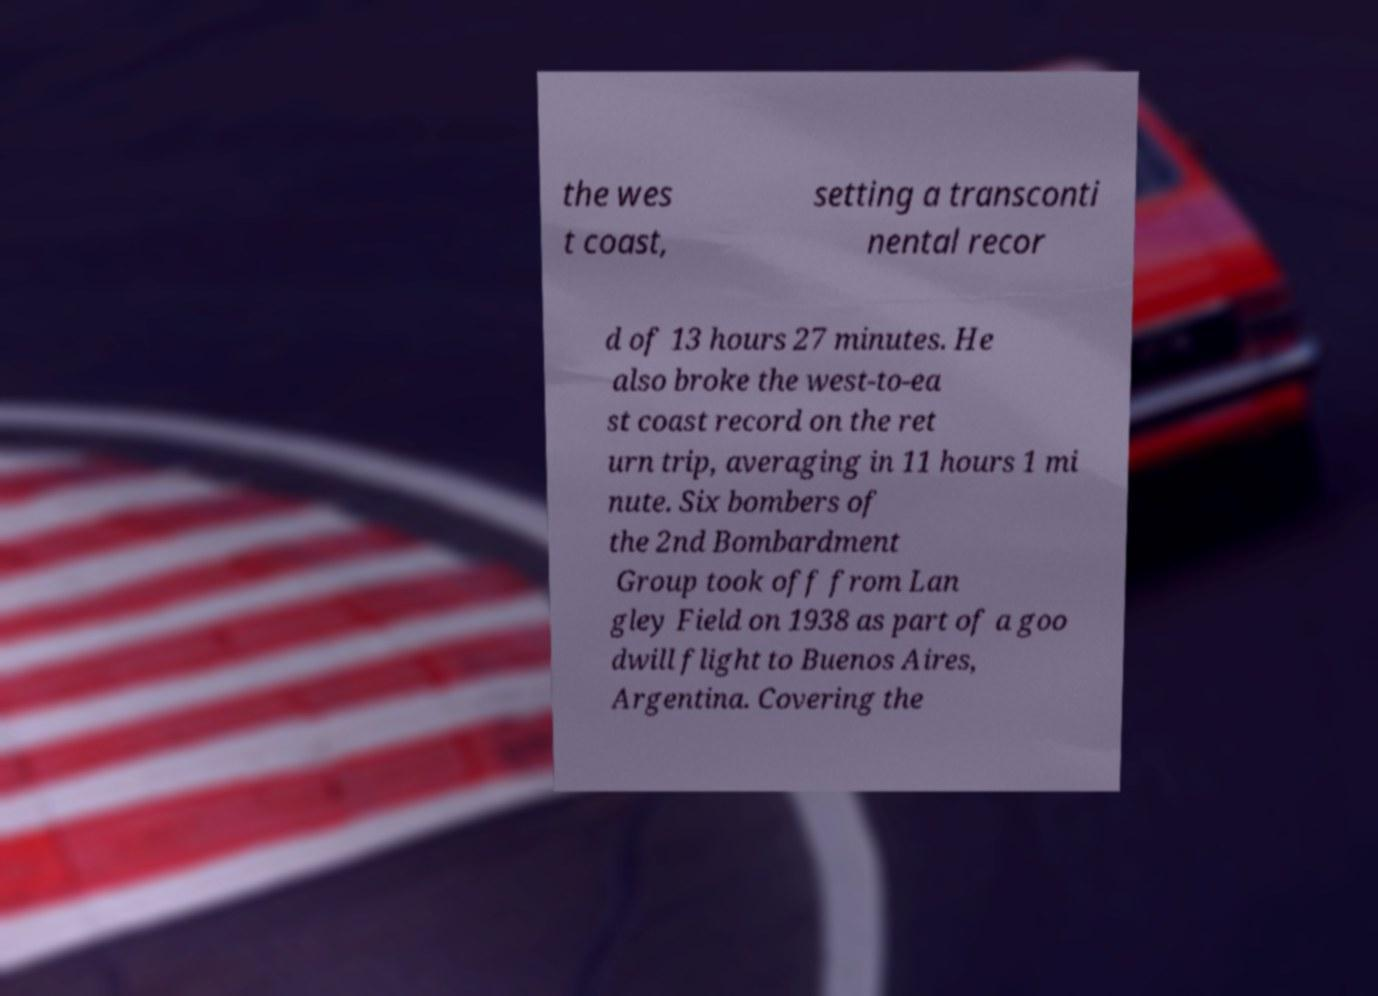Could you extract and type out the text from this image? the wes t coast, setting a transconti nental recor d of 13 hours 27 minutes. He also broke the west-to-ea st coast record on the ret urn trip, averaging in 11 hours 1 mi nute. Six bombers of the 2nd Bombardment Group took off from Lan gley Field on 1938 as part of a goo dwill flight to Buenos Aires, Argentina. Covering the 